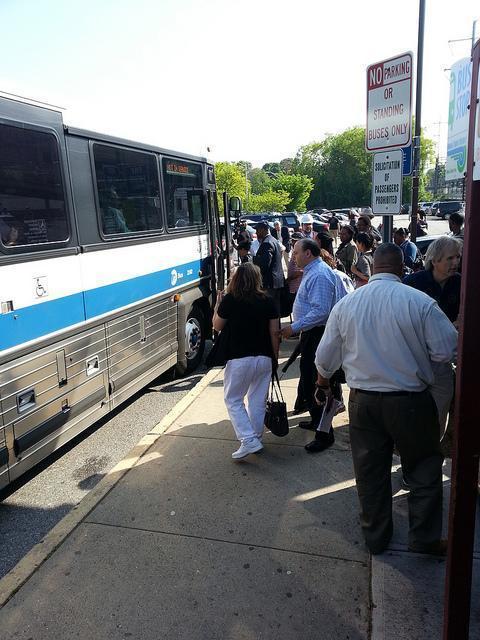What activity is prohibited here?
Make your selection and explain in format: 'Answer: answer
Rationale: rationale.'
Options: Eating, busses, taxis, boarding. Answer: taxis.
Rationale: People are gathered on a sidewalk at a bus stop. 